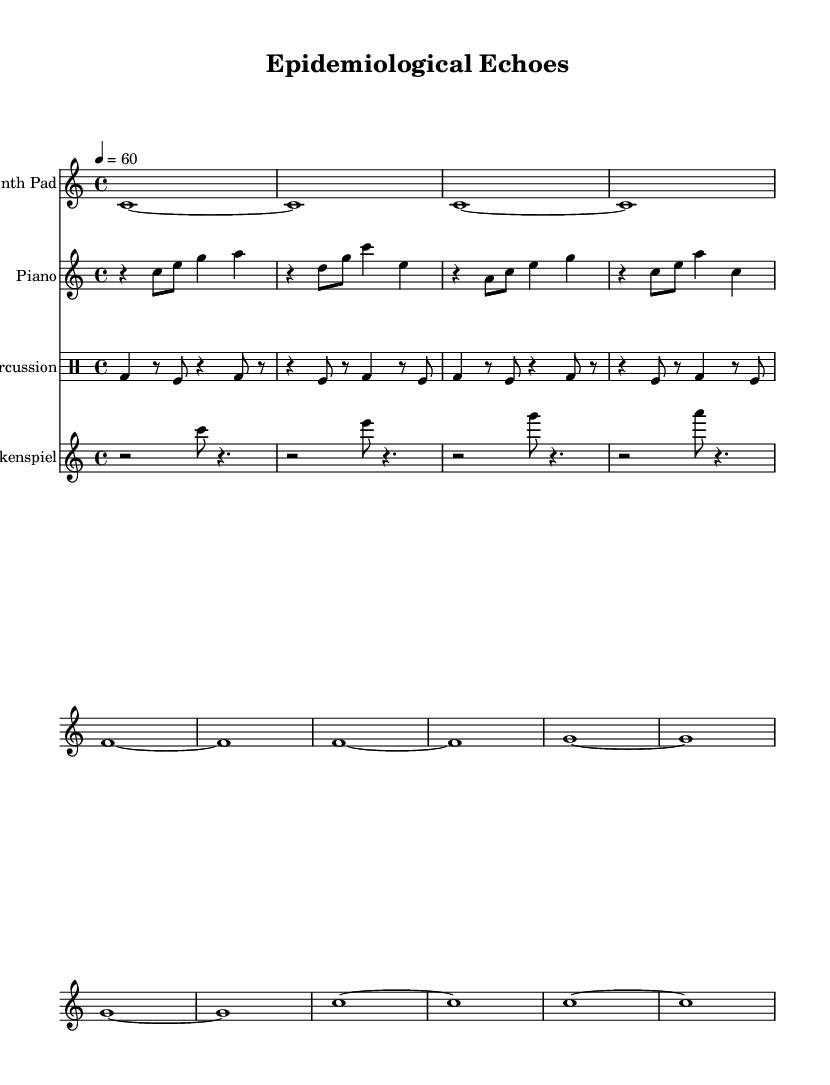What is the key signature of this music? The key signature is indicated at the beginning of the music and shows no sharps or flats, which corresponds to C major.
Answer: C major What is the time signature of this music? The time signature is placed at the beginning next to the key signature, and it shows a 4 over 4, indicating four beats per measure.
Answer: 4/4 What is the tempo marking for this piece? The tempo marking is found above the staff, indicating the speed at which the music should be played, which is a quarter note equals sixty beats per minute.
Answer: 60 How many instruments are indicated in this score? The score displays four distinct staves, one for each instrument, which are Synth Pad, Piano, Percussion, and Glockenspiel, making a total of four instruments.
Answer: 4 Which instrument plays the highest pitch in this piece? The glockenspiel is transposed two octaves higher than the others, and its notes are listed in the treble clef, giving it the highest pitch range in the score.
Answer: Glockenspiel What rhythmic pattern is represented by the percussion section? The percussion section alternates between bass drum and tom fills, making the rhythmic pattern distinct and energetic; it features rests and different note lengths throughout.
Answer: Alternating bass drum and tomfills How does the melody of the Synth Pad differ from the Piano part? The Synth Pad consists of sustained whole notes, creating an ambient sound, while the Piano part features shorter, syncopated rhythms with a series of eighth and quarter notes, creating a contrast in texture.
Answer: Ambience vs. syncopation 